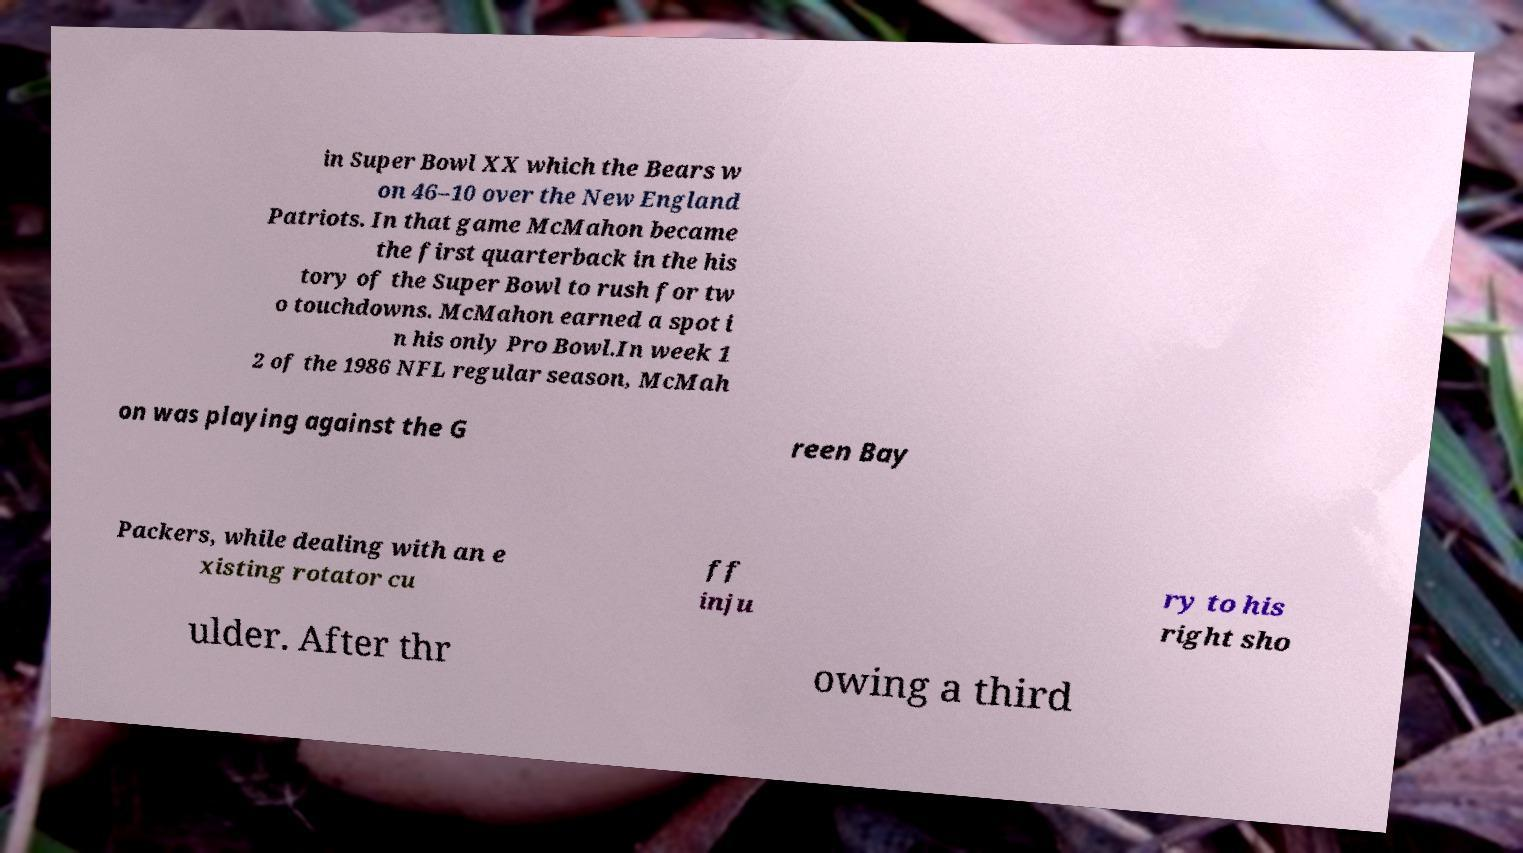Could you assist in decoding the text presented in this image and type it out clearly? in Super Bowl XX which the Bears w on 46–10 over the New England Patriots. In that game McMahon became the first quarterback in the his tory of the Super Bowl to rush for tw o touchdowns. McMahon earned a spot i n his only Pro Bowl.In week 1 2 of the 1986 NFL regular season, McMah on was playing against the G reen Bay Packers, while dealing with an e xisting rotator cu ff inju ry to his right sho ulder. After thr owing a third 